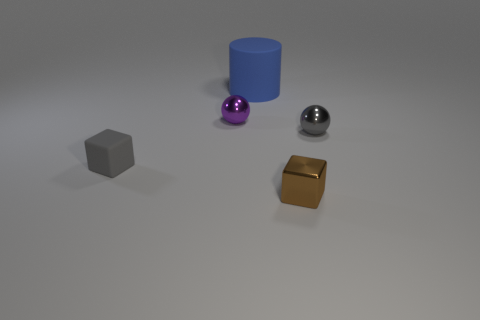There is a object that is in front of the gray matte block; what is its shape?
Offer a terse response. Cube. Are there any rubber things left of the blue rubber thing?
Offer a terse response. Yes. Is there any other thing that has the same size as the blue cylinder?
Your response must be concise. No. There is a cube that is made of the same material as the tiny purple sphere; what color is it?
Make the answer very short. Brown. Does the block to the left of the big blue thing have the same color as the ball that is right of the cylinder?
Your answer should be very brief. Yes. How many cubes are either small gray things or tiny rubber things?
Keep it short and to the point. 1. Are there the same number of matte things behind the tiny gray metallic ball and tiny blocks?
Provide a succinct answer. No. What material is the gray thing that is right of the tiny cube that is left of the metallic ball behind the gray ball made of?
Your answer should be very brief. Metal. There is a small thing that is the same color as the tiny rubber cube; what is its material?
Ensure brevity in your answer.  Metal. What number of objects are either gray things that are right of the blue matte cylinder or blue cubes?
Make the answer very short. 1. 